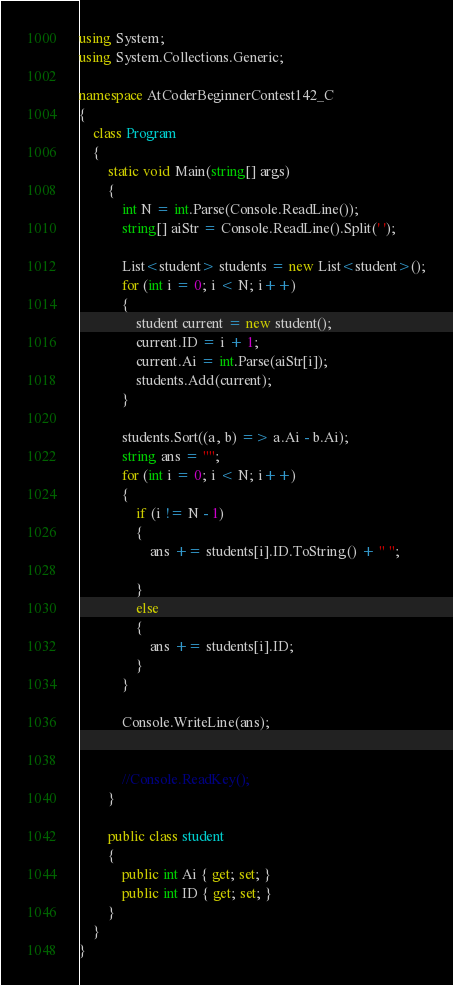<code> <loc_0><loc_0><loc_500><loc_500><_C#_>using System;
using System.Collections.Generic;

namespace AtCoderBeginnerContest142_C
{
    class Program
    {
        static void Main(string[] args)
        {
            int N = int.Parse(Console.ReadLine());
            string[] aiStr = Console.ReadLine().Split(' ');

            List<student> students = new List<student>();
            for (int i = 0; i < N; i++)
            {
                student current = new student();
                current.ID = i + 1;
                current.Ai = int.Parse(aiStr[i]);
                students.Add(current);
            }

            students.Sort((a, b) => a.Ai - b.Ai);
            string ans = "";
            for (int i = 0; i < N; i++)
            {
                if (i != N - 1)
                {
                    ans += students[i].ID.ToString() + " ";

                }
                else
                {
                    ans += students[i].ID;
                }
            }

            Console.WriteLine(ans);


            //Console.ReadKey();
        }

        public class student
        {
            public int Ai { get; set; }
            public int ID { get; set; }
        }
    }
}
</code> 